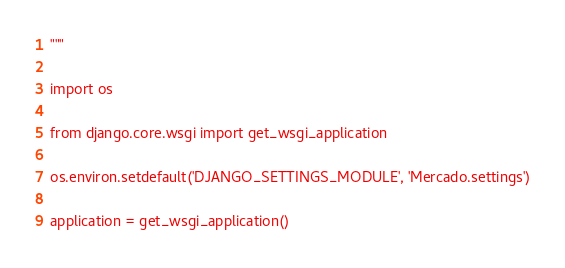Convert code to text. <code><loc_0><loc_0><loc_500><loc_500><_Python_>"""

import os

from django.core.wsgi import get_wsgi_application

os.environ.setdefault('DJANGO_SETTINGS_MODULE', 'Mercado.settings')

application = get_wsgi_application()
</code> 